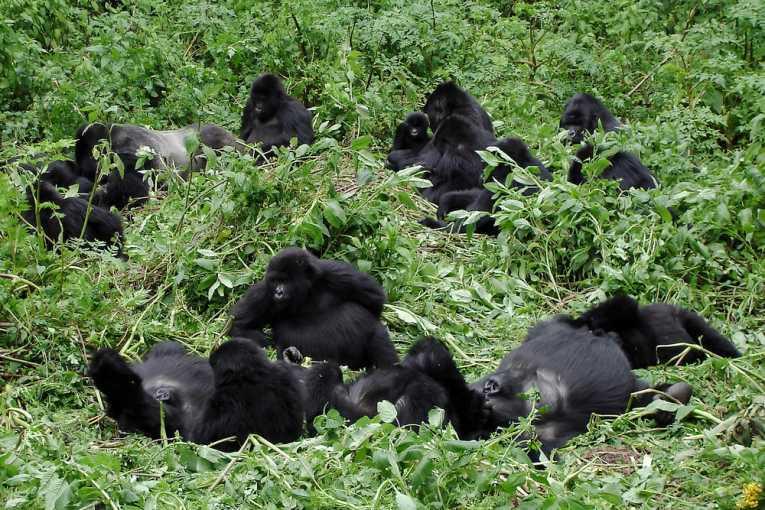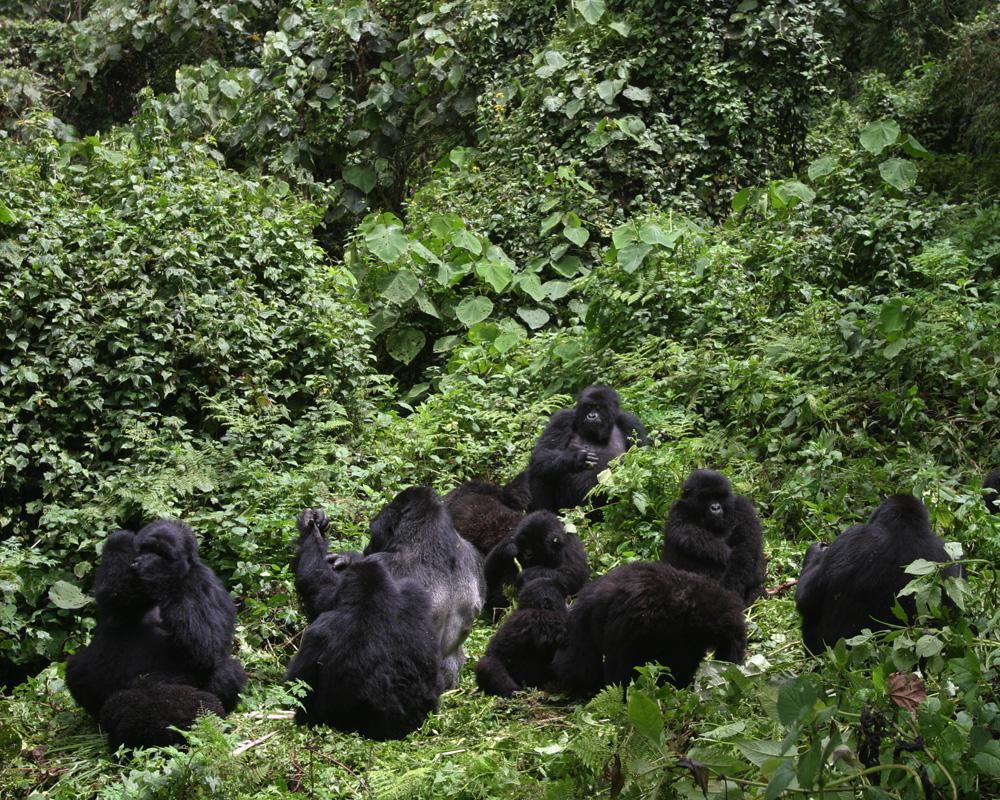The first image is the image on the left, the second image is the image on the right. Assess this claim about the two images: "An image shows exactly one adult gorilla in close contact with a baby gorilla.". Correct or not? Answer yes or no. No. The first image is the image on the left, the second image is the image on the right. Considering the images on both sides, is "A single adult gorilla is holding a baby." valid? Answer yes or no. No. 